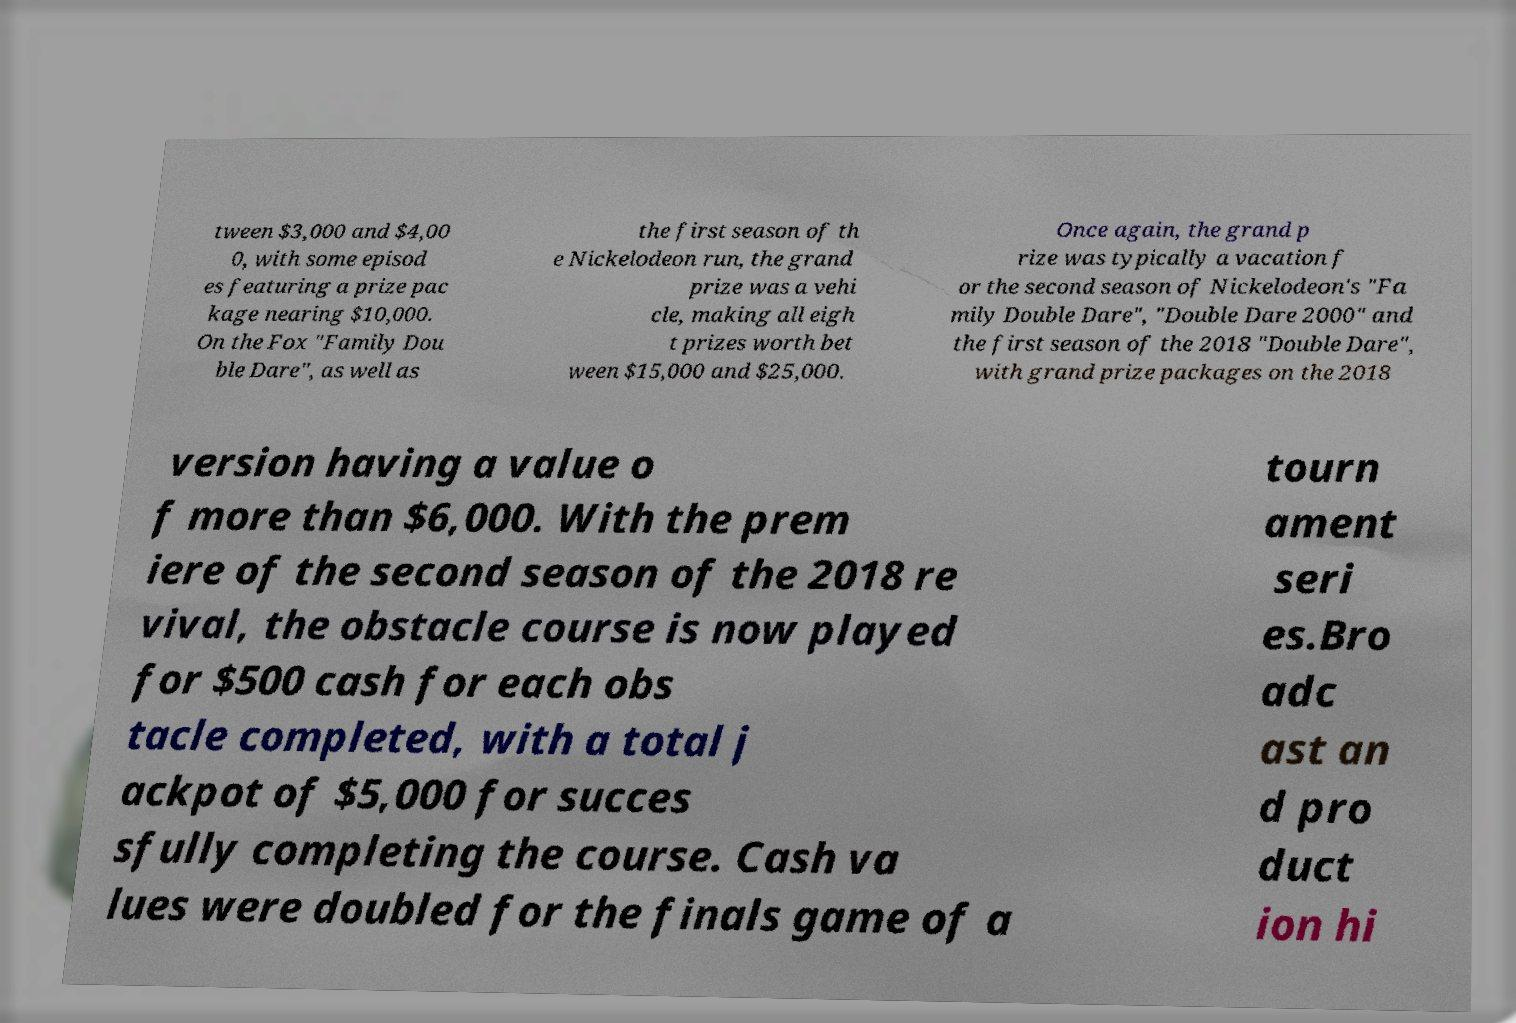I need the written content from this picture converted into text. Can you do that? tween $3,000 and $4,00 0, with some episod es featuring a prize pac kage nearing $10,000. On the Fox "Family Dou ble Dare", as well as the first season of th e Nickelodeon run, the grand prize was a vehi cle, making all eigh t prizes worth bet ween $15,000 and $25,000. Once again, the grand p rize was typically a vacation f or the second season of Nickelodeon's "Fa mily Double Dare", "Double Dare 2000" and the first season of the 2018 "Double Dare", with grand prize packages on the 2018 version having a value o f more than $6,000. With the prem iere of the second season of the 2018 re vival, the obstacle course is now played for $500 cash for each obs tacle completed, with a total j ackpot of $5,000 for succes sfully completing the course. Cash va lues were doubled for the finals game of a tourn ament seri es.Bro adc ast an d pro duct ion hi 